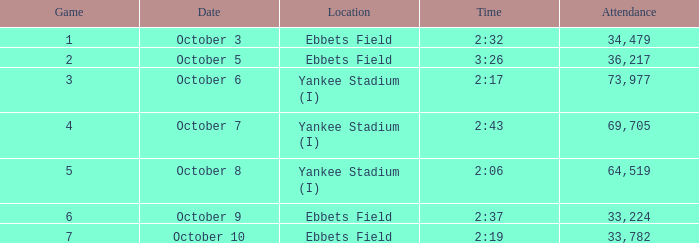What is the location of the game that has a number smaller than 2? Ebbets Field. 